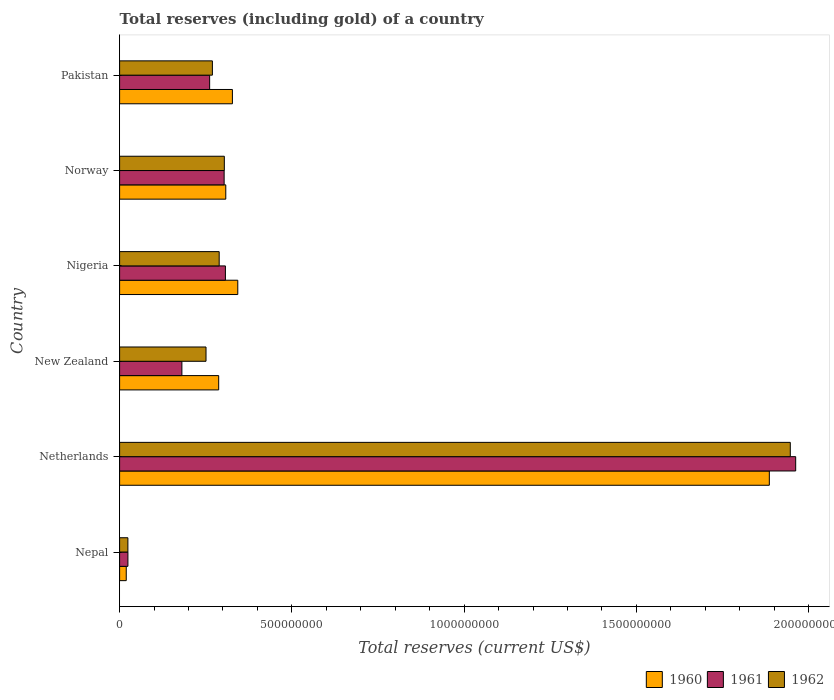How many groups of bars are there?
Provide a short and direct response. 6. Are the number of bars on each tick of the Y-axis equal?
Offer a very short reply. Yes. How many bars are there on the 1st tick from the bottom?
Provide a short and direct response. 3. What is the total reserves (including gold) in 1961 in New Zealand?
Provide a succinct answer. 1.81e+08. Across all countries, what is the maximum total reserves (including gold) in 1961?
Provide a short and direct response. 1.96e+09. Across all countries, what is the minimum total reserves (including gold) in 1961?
Keep it short and to the point. 2.41e+07. In which country was the total reserves (including gold) in 1960 maximum?
Make the answer very short. Netherlands. In which country was the total reserves (including gold) in 1962 minimum?
Offer a terse response. Nepal. What is the total total reserves (including gold) in 1960 in the graph?
Provide a short and direct response. 3.17e+09. What is the difference between the total reserves (including gold) in 1961 in Netherlands and that in Norway?
Your answer should be compact. 1.66e+09. What is the difference between the total reserves (including gold) in 1961 in Norway and the total reserves (including gold) in 1962 in Nigeria?
Provide a succinct answer. 1.44e+07. What is the average total reserves (including gold) in 1960 per country?
Offer a terse response. 5.29e+08. What is the difference between the total reserves (including gold) in 1961 and total reserves (including gold) in 1960 in Pakistan?
Ensure brevity in your answer.  -6.61e+07. In how many countries, is the total reserves (including gold) in 1960 greater than 1000000000 US$?
Offer a terse response. 1. What is the ratio of the total reserves (including gold) in 1960 in Nigeria to that in Norway?
Your answer should be very brief. 1.11. Is the total reserves (including gold) in 1960 in Netherlands less than that in Nigeria?
Your answer should be very brief. No. Is the difference between the total reserves (including gold) in 1961 in Nepal and Norway greater than the difference between the total reserves (including gold) in 1960 in Nepal and Norway?
Your answer should be very brief. Yes. What is the difference between the highest and the second highest total reserves (including gold) in 1961?
Make the answer very short. 1.66e+09. What is the difference between the highest and the lowest total reserves (including gold) in 1962?
Your response must be concise. 1.92e+09. In how many countries, is the total reserves (including gold) in 1962 greater than the average total reserves (including gold) in 1962 taken over all countries?
Give a very brief answer. 1. Is the sum of the total reserves (including gold) in 1961 in Netherlands and Nigeria greater than the maximum total reserves (including gold) in 1960 across all countries?
Your answer should be compact. Yes. What does the 2nd bar from the top in Pakistan represents?
Give a very brief answer. 1961. How many bars are there?
Your response must be concise. 18. Are all the bars in the graph horizontal?
Keep it short and to the point. Yes. How many countries are there in the graph?
Make the answer very short. 6. What is the difference between two consecutive major ticks on the X-axis?
Provide a succinct answer. 5.00e+08. Are the values on the major ticks of X-axis written in scientific E-notation?
Keep it short and to the point. No. Does the graph contain any zero values?
Your response must be concise. No. Where does the legend appear in the graph?
Make the answer very short. Bottom right. How many legend labels are there?
Offer a very short reply. 3. What is the title of the graph?
Make the answer very short. Total reserves (including gold) of a country. Does "2009" appear as one of the legend labels in the graph?
Give a very brief answer. No. What is the label or title of the X-axis?
Keep it short and to the point. Total reserves (current US$). What is the Total reserves (current US$) of 1960 in Nepal?
Give a very brief answer. 1.93e+07. What is the Total reserves (current US$) of 1961 in Nepal?
Make the answer very short. 2.41e+07. What is the Total reserves (current US$) in 1962 in Nepal?
Your answer should be very brief. 2.40e+07. What is the Total reserves (current US$) of 1960 in Netherlands?
Make the answer very short. 1.89e+09. What is the Total reserves (current US$) in 1961 in Netherlands?
Ensure brevity in your answer.  1.96e+09. What is the Total reserves (current US$) of 1962 in Netherlands?
Offer a very short reply. 1.95e+09. What is the Total reserves (current US$) of 1960 in New Zealand?
Provide a short and direct response. 2.88e+08. What is the Total reserves (current US$) of 1961 in New Zealand?
Keep it short and to the point. 1.81e+08. What is the Total reserves (current US$) of 1962 in New Zealand?
Your response must be concise. 2.51e+08. What is the Total reserves (current US$) in 1960 in Nigeria?
Provide a succinct answer. 3.43e+08. What is the Total reserves (current US$) in 1961 in Nigeria?
Make the answer very short. 3.07e+08. What is the Total reserves (current US$) in 1962 in Nigeria?
Give a very brief answer. 2.89e+08. What is the Total reserves (current US$) of 1960 in Norway?
Give a very brief answer. 3.08e+08. What is the Total reserves (current US$) in 1961 in Norway?
Your answer should be compact. 3.03e+08. What is the Total reserves (current US$) in 1962 in Norway?
Offer a terse response. 3.04e+08. What is the Total reserves (current US$) in 1960 in Pakistan?
Your answer should be very brief. 3.27e+08. What is the Total reserves (current US$) of 1961 in Pakistan?
Offer a very short reply. 2.61e+08. What is the Total reserves (current US$) of 1962 in Pakistan?
Provide a short and direct response. 2.69e+08. Across all countries, what is the maximum Total reserves (current US$) in 1960?
Your answer should be very brief. 1.89e+09. Across all countries, what is the maximum Total reserves (current US$) of 1961?
Your response must be concise. 1.96e+09. Across all countries, what is the maximum Total reserves (current US$) in 1962?
Give a very brief answer. 1.95e+09. Across all countries, what is the minimum Total reserves (current US$) in 1960?
Your answer should be very brief. 1.93e+07. Across all countries, what is the minimum Total reserves (current US$) in 1961?
Offer a very short reply. 2.41e+07. Across all countries, what is the minimum Total reserves (current US$) of 1962?
Give a very brief answer. 2.40e+07. What is the total Total reserves (current US$) of 1960 in the graph?
Provide a succinct answer. 3.17e+09. What is the total Total reserves (current US$) of 1961 in the graph?
Your answer should be compact. 3.04e+09. What is the total Total reserves (current US$) of 1962 in the graph?
Your response must be concise. 3.08e+09. What is the difference between the Total reserves (current US$) of 1960 in Nepal and that in Netherlands?
Provide a short and direct response. -1.87e+09. What is the difference between the Total reserves (current US$) in 1961 in Nepal and that in Netherlands?
Offer a terse response. -1.94e+09. What is the difference between the Total reserves (current US$) of 1962 in Nepal and that in Netherlands?
Ensure brevity in your answer.  -1.92e+09. What is the difference between the Total reserves (current US$) of 1960 in Nepal and that in New Zealand?
Your response must be concise. -2.68e+08. What is the difference between the Total reserves (current US$) of 1961 in Nepal and that in New Zealand?
Ensure brevity in your answer.  -1.57e+08. What is the difference between the Total reserves (current US$) of 1962 in Nepal and that in New Zealand?
Provide a succinct answer. -2.27e+08. What is the difference between the Total reserves (current US$) in 1960 in Nepal and that in Nigeria?
Provide a succinct answer. -3.24e+08. What is the difference between the Total reserves (current US$) of 1961 in Nepal and that in Nigeria?
Your answer should be compact. -2.83e+08. What is the difference between the Total reserves (current US$) in 1962 in Nepal and that in Nigeria?
Ensure brevity in your answer.  -2.65e+08. What is the difference between the Total reserves (current US$) in 1960 in Nepal and that in Norway?
Provide a succinct answer. -2.89e+08. What is the difference between the Total reserves (current US$) of 1961 in Nepal and that in Norway?
Your response must be concise. -2.79e+08. What is the difference between the Total reserves (current US$) in 1962 in Nepal and that in Norway?
Offer a very short reply. -2.80e+08. What is the difference between the Total reserves (current US$) in 1960 in Nepal and that in Pakistan?
Your answer should be compact. -3.08e+08. What is the difference between the Total reserves (current US$) in 1961 in Nepal and that in Pakistan?
Provide a succinct answer. -2.37e+08. What is the difference between the Total reserves (current US$) of 1962 in Nepal and that in Pakistan?
Your answer should be very brief. -2.45e+08. What is the difference between the Total reserves (current US$) in 1960 in Netherlands and that in New Zealand?
Ensure brevity in your answer.  1.60e+09. What is the difference between the Total reserves (current US$) in 1961 in Netherlands and that in New Zealand?
Ensure brevity in your answer.  1.78e+09. What is the difference between the Total reserves (current US$) in 1962 in Netherlands and that in New Zealand?
Offer a very short reply. 1.70e+09. What is the difference between the Total reserves (current US$) in 1960 in Netherlands and that in Nigeria?
Your response must be concise. 1.54e+09. What is the difference between the Total reserves (current US$) of 1961 in Netherlands and that in Nigeria?
Keep it short and to the point. 1.66e+09. What is the difference between the Total reserves (current US$) in 1962 in Netherlands and that in Nigeria?
Ensure brevity in your answer.  1.66e+09. What is the difference between the Total reserves (current US$) in 1960 in Netherlands and that in Norway?
Provide a succinct answer. 1.58e+09. What is the difference between the Total reserves (current US$) of 1961 in Netherlands and that in Norway?
Provide a succinct answer. 1.66e+09. What is the difference between the Total reserves (current US$) in 1962 in Netherlands and that in Norway?
Provide a succinct answer. 1.64e+09. What is the difference between the Total reserves (current US$) of 1960 in Netherlands and that in Pakistan?
Offer a terse response. 1.56e+09. What is the difference between the Total reserves (current US$) in 1961 in Netherlands and that in Pakistan?
Make the answer very short. 1.70e+09. What is the difference between the Total reserves (current US$) of 1962 in Netherlands and that in Pakistan?
Provide a short and direct response. 1.68e+09. What is the difference between the Total reserves (current US$) of 1960 in New Zealand and that in Nigeria?
Your response must be concise. -5.54e+07. What is the difference between the Total reserves (current US$) of 1961 in New Zealand and that in Nigeria?
Offer a very short reply. -1.26e+08. What is the difference between the Total reserves (current US$) in 1962 in New Zealand and that in Nigeria?
Make the answer very short. -3.82e+07. What is the difference between the Total reserves (current US$) of 1960 in New Zealand and that in Norway?
Ensure brevity in your answer.  -2.06e+07. What is the difference between the Total reserves (current US$) of 1961 in New Zealand and that in Norway?
Offer a terse response. -1.23e+08. What is the difference between the Total reserves (current US$) in 1962 in New Zealand and that in Norway?
Offer a very short reply. -5.32e+07. What is the difference between the Total reserves (current US$) of 1960 in New Zealand and that in Pakistan?
Give a very brief answer. -3.98e+07. What is the difference between the Total reserves (current US$) in 1961 in New Zealand and that in Pakistan?
Make the answer very short. -8.05e+07. What is the difference between the Total reserves (current US$) of 1962 in New Zealand and that in Pakistan?
Your response must be concise. -1.85e+07. What is the difference between the Total reserves (current US$) of 1960 in Nigeria and that in Norway?
Give a very brief answer. 3.48e+07. What is the difference between the Total reserves (current US$) in 1961 in Nigeria and that in Norway?
Your answer should be very brief. 3.64e+06. What is the difference between the Total reserves (current US$) of 1962 in Nigeria and that in Norway?
Provide a short and direct response. -1.50e+07. What is the difference between the Total reserves (current US$) in 1960 in Nigeria and that in Pakistan?
Your response must be concise. 1.56e+07. What is the difference between the Total reserves (current US$) of 1961 in Nigeria and that in Pakistan?
Your response must be concise. 4.58e+07. What is the difference between the Total reserves (current US$) in 1962 in Nigeria and that in Pakistan?
Keep it short and to the point. 1.97e+07. What is the difference between the Total reserves (current US$) of 1960 in Norway and that in Pakistan?
Offer a terse response. -1.92e+07. What is the difference between the Total reserves (current US$) of 1961 in Norway and that in Pakistan?
Your answer should be very brief. 4.21e+07. What is the difference between the Total reserves (current US$) of 1962 in Norway and that in Pakistan?
Offer a terse response. 3.47e+07. What is the difference between the Total reserves (current US$) of 1960 in Nepal and the Total reserves (current US$) of 1961 in Netherlands?
Offer a terse response. -1.94e+09. What is the difference between the Total reserves (current US$) of 1960 in Nepal and the Total reserves (current US$) of 1962 in Netherlands?
Give a very brief answer. -1.93e+09. What is the difference between the Total reserves (current US$) in 1961 in Nepal and the Total reserves (current US$) in 1962 in Netherlands?
Provide a succinct answer. -1.92e+09. What is the difference between the Total reserves (current US$) in 1960 in Nepal and the Total reserves (current US$) in 1961 in New Zealand?
Offer a terse response. -1.62e+08. What is the difference between the Total reserves (current US$) in 1960 in Nepal and the Total reserves (current US$) in 1962 in New Zealand?
Provide a short and direct response. -2.32e+08. What is the difference between the Total reserves (current US$) in 1961 in Nepal and the Total reserves (current US$) in 1962 in New Zealand?
Offer a very short reply. -2.27e+08. What is the difference between the Total reserves (current US$) of 1960 in Nepal and the Total reserves (current US$) of 1961 in Nigeria?
Give a very brief answer. -2.88e+08. What is the difference between the Total reserves (current US$) in 1960 in Nepal and the Total reserves (current US$) in 1962 in Nigeria?
Give a very brief answer. -2.70e+08. What is the difference between the Total reserves (current US$) in 1961 in Nepal and the Total reserves (current US$) in 1962 in Nigeria?
Provide a succinct answer. -2.65e+08. What is the difference between the Total reserves (current US$) of 1960 in Nepal and the Total reserves (current US$) of 1961 in Norway?
Provide a short and direct response. -2.84e+08. What is the difference between the Total reserves (current US$) in 1960 in Nepal and the Total reserves (current US$) in 1962 in Norway?
Offer a very short reply. -2.85e+08. What is the difference between the Total reserves (current US$) of 1961 in Nepal and the Total reserves (current US$) of 1962 in Norway?
Your answer should be compact. -2.80e+08. What is the difference between the Total reserves (current US$) of 1960 in Nepal and the Total reserves (current US$) of 1961 in Pakistan?
Your response must be concise. -2.42e+08. What is the difference between the Total reserves (current US$) in 1960 in Nepal and the Total reserves (current US$) in 1962 in Pakistan?
Give a very brief answer. -2.50e+08. What is the difference between the Total reserves (current US$) of 1961 in Nepal and the Total reserves (current US$) of 1962 in Pakistan?
Your answer should be very brief. -2.45e+08. What is the difference between the Total reserves (current US$) in 1960 in Netherlands and the Total reserves (current US$) in 1961 in New Zealand?
Your response must be concise. 1.70e+09. What is the difference between the Total reserves (current US$) in 1960 in Netherlands and the Total reserves (current US$) in 1962 in New Zealand?
Your answer should be compact. 1.63e+09. What is the difference between the Total reserves (current US$) of 1961 in Netherlands and the Total reserves (current US$) of 1962 in New Zealand?
Your answer should be very brief. 1.71e+09. What is the difference between the Total reserves (current US$) of 1960 in Netherlands and the Total reserves (current US$) of 1961 in Nigeria?
Make the answer very short. 1.58e+09. What is the difference between the Total reserves (current US$) in 1960 in Netherlands and the Total reserves (current US$) in 1962 in Nigeria?
Offer a terse response. 1.60e+09. What is the difference between the Total reserves (current US$) of 1961 in Netherlands and the Total reserves (current US$) of 1962 in Nigeria?
Offer a very short reply. 1.67e+09. What is the difference between the Total reserves (current US$) of 1960 in Netherlands and the Total reserves (current US$) of 1961 in Norway?
Offer a terse response. 1.58e+09. What is the difference between the Total reserves (current US$) in 1960 in Netherlands and the Total reserves (current US$) in 1962 in Norway?
Keep it short and to the point. 1.58e+09. What is the difference between the Total reserves (current US$) in 1961 in Netherlands and the Total reserves (current US$) in 1962 in Norway?
Provide a succinct answer. 1.66e+09. What is the difference between the Total reserves (current US$) of 1960 in Netherlands and the Total reserves (current US$) of 1961 in Pakistan?
Offer a terse response. 1.62e+09. What is the difference between the Total reserves (current US$) in 1960 in Netherlands and the Total reserves (current US$) in 1962 in Pakistan?
Give a very brief answer. 1.62e+09. What is the difference between the Total reserves (current US$) of 1961 in Netherlands and the Total reserves (current US$) of 1962 in Pakistan?
Offer a terse response. 1.69e+09. What is the difference between the Total reserves (current US$) in 1960 in New Zealand and the Total reserves (current US$) in 1961 in Nigeria?
Offer a very short reply. -1.95e+07. What is the difference between the Total reserves (current US$) of 1960 in New Zealand and the Total reserves (current US$) of 1962 in Nigeria?
Your response must be concise. -1.43e+06. What is the difference between the Total reserves (current US$) of 1961 in New Zealand and the Total reserves (current US$) of 1962 in Nigeria?
Your answer should be compact. -1.08e+08. What is the difference between the Total reserves (current US$) of 1960 in New Zealand and the Total reserves (current US$) of 1961 in Norway?
Give a very brief answer. -1.58e+07. What is the difference between the Total reserves (current US$) of 1960 in New Zealand and the Total reserves (current US$) of 1962 in Norway?
Give a very brief answer. -1.64e+07. What is the difference between the Total reserves (current US$) of 1961 in New Zealand and the Total reserves (current US$) of 1962 in Norway?
Offer a very short reply. -1.23e+08. What is the difference between the Total reserves (current US$) of 1960 in New Zealand and the Total reserves (current US$) of 1961 in Pakistan?
Keep it short and to the point. 2.63e+07. What is the difference between the Total reserves (current US$) of 1960 in New Zealand and the Total reserves (current US$) of 1962 in Pakistan?
Offer a terse response. 1.83e+07. What is the difference between the Total reserves (current US$) of 1961 in New Zealand and the Total reserves (current US$) of 1962 in Pakistan?
Provide a short and direct response. -8.85e+07. What is the difference between the Total reserves (current US$) of 1960 in Nigeria and the Total reserves (current US$) of 1961 in Norway?
Offer a terse response. 3.96e+07. What is the difference between the Total reserves (current US$) in 1960 in Nigeria and the Total reserves (current US$) in 1962 in Norway?
Make the answer very short. 3.90e+07. What is the difference between the Total reserves (current US$) of 1961 in Nigeria and the Total reserves (current US$) of 1962 in Norway?
Provide a short and direct response. 3.09e+06. What is the difference between the Total reserves (current US$) of 1960 in Nigeria and the Total reserves (current US$) of 1961 in Pakistan?
Your answer should be compact. 8.17e+07. What is the difference between the Total reserves (current US$) in 1960 in Nigeria and the Total reserves (current US$) in 1962 in Pakistan?
Give a very brief answer. 7.37e+07. What is the difference between the Total reserves (current US$) of 1961 in Nigeria and the Total reserves (current US$) of 1962 in Pakistan?
Your response must be concise. 3.78e+07. What is the difference between the Total reserves (current US$) in 1960 in Norway and the Total reserves (current US$) in 1961 in Pakistan?
Your answer should be very brief. 4.69e+07. What is the difference between the Total reserves (current US$) of 1960 in Norway and the Total reserves (current US$) of 1962 in Pakistan?
Ensure brevity in your answer.  3.89e+07. What is the difference between the Total reserves (current US$) of 1961 in Norway and the Total reserves (current US$) of 1962 in Pakistan?
Your answer should be very brief. 3.41e+07. What is the average Total reserves (current US$) in 1960 per country?
Give a very brief answer. 5.29e+08. What is the average Total reserves (current US$) of 1961 per country?
Provide a succinct answer. 5.07e+08. What is the average Total reserves (current US$) of 1962 per country?
Make the answer very short. 5.14e+08. What is the difference between the Total reserves (current US$) in 1960 and Total reserves (current US$) in 1961 in Nepal?
Provide a succinct answer. -4.88e+06. What is the difference between the Total reserves (current US$) of 1960 and Total reserves (current US$) of 1962 in Nepal?
Offer a very short reply. -4.77e+06. What is the difference between the Total reserves (current US$) in 1961 and Total reserves (current US$) in 1962 in Nepal?
Give a very brief answer. 1.04e+05. What is the difference between the Total reserves (current US$) in 1960 and Total reserves (current US$) in 1961 in Netherlands?
Ensure brevity in your answer.  -7.65e+07. What is the difference between the Total reserves (current US$) in 1960 and Total reserves (current US$) in 1962 in Netherlands?
Your response must be concise. -6.09e+07. What is the difference between the Total reserves (current US$) of 1961 and Total reserves (current US$) of 1962 in Netherlands?
Make the answer very short. 1.56e+07. What is the difference between the Total reserves (current US$) of 1960 and Total reserves (current US$) of 1961 in New Zealand?
Your answer should be compact. 1.07e+08. What is the difference between the Total reserves (current US$) in 1960 and Total reserves (current US$) in 1962 in New Zealand?
Ensure brevity in your answer.  3.68e+07. What is the difference between the Total reserves (current US$) in 1961 and Total reserves (current US$) in 1962 in New Zealand?
Offer a very short reply. -7.00e+07. What is the difference between the Total reserves (current US$) of 1960 and Total reserves (current US$) of 1961 in Nigeria?
Give a very brief answer. 3.59e+07. What is the difference between the Total reserves (current US$) in 1960 and Total reserves (current US$) in 1962 in Nigeria?
Offer a very short reply. 5.40e+07. What is the difference between the Total reserves (current US$) of 1961 and Total reserves (current US$) of 1962 in Nigeria?
Ensure brevity in your answer.  1.80e+07. What is the difference between the Total reserves (current US$) of 1960 and Total reserves (current US$) of 1961 in Norway?
Keep it short and to the point. 4.75e+06. What is the difference between the Total reserves (current US$) in 1960 and Total reserves (current US$) in 1962 in Norway?
Keep it short and to the point. 4.20e+06. What is the difference between the Total reserves (current US$) of 1961 and Total reserves (current US$) of 1962 in Norway?
Give a very brief answer. -5.46e+05. What is the difference between the Total reserves (current US$) of 1960 and Total reserves (current US$) of 1961 in Pakistan?
Provide a succinct answer. 6.61e+07. What is the difference between the Total reserves (current US$) in 1960 and Total reserves (current US$) in 1962 in Pakistan?
Offer a terse response. 5.81e+07. What is the difference between the Total reserves (current US$) in 1961 and Total reserves (current US$) in 1962 in Pakistan?
Keep it short and to the point. -8.01e+06. What is the ratio of the Total reserves (current US$) in 1960 in Nepal to that in Netherlands?
Offer a terse response. 0.01. What is the ratio of the Total reserves (current US$) in 1961 in Nepal to that in Netherlands?
Give a very brief answer. 0.01. What is the ratio of the Total reserves (current US$) of 1962 in Nepal to that in Netherlands?
Provide a succinct answer. 0.01. What is the ratio of the Total reserves (current US$) in 1960 in Nepal to that in New Zealand?
Offer a very short reply. 0.07. What is the ratio of the Total reserves (current US$) of 1961 in Nepal to that in New Zealand?
Your answer should be very brief. 0.13. What is the ratio of the Total reserves (current US$) of 1962 in Nepal to that in New Zealand?
Keep it short and to the point. 0.1. What is the ratio of the Total reserves (current US$) in 1960 in Nepal to that in Nigeria?
Keep it short and to the point. 0.06. What is the ratio of the Total reserves (current US$) of 1961 in Nepal to that in Nigeria?
Give a very brief answer. 0.08. What is the ratio of the Total reserves (current US$) in 1962 in Nepal to that in Nigeria?
Provide a succinct answer. 0.08. What is the ratio of the Total reserves (current US$) in 1960 in Nepal to that in Norway?
Provide a short and direct response. 0.06. What is the ratio of the Total reserves (current US$) of 1961 in Nepal to that in Norway?
Provide a short and direct response. 0.08. What is the ratio of the Total reserves (current US$) of 1962 in Nepal to that in Norway?
Provide a succinct answer. 0.08. What is the ratio of the Total reserves (current US$) in 1960 in Nepal to that in Pakistan?
Provide a short and direct response. 0.06. What is the ratio of the Total reserves (current US$) of 1961 in Nepal to that in Pakistan?
Your answer should be very brief. 0.09. What is the ratio of the Total reserves (current US$) in 1962 in Nepal to that in Pakistan?
Keep it short and to the point. 0.09. What is the ratio of the Total reserves (current US$) of 1960 in Netherlands to that in New Zealand?
Make the answer very short. 6.56. What is the ratio of the Total reserves (current US$) in 1961 in Netherlands to that in New Zealand?
Offer a terse response. 10.85. What is the ratio of the Total reserves (current US$) in 1962 in Netherlands to that in New Zealand?
Your response must be concise. 7.76. What is the ratio of the Total reserves (current US$) in 1960 in Netherlands to that in Nigeria?
Provide a short and direct response. 5.5. What is the ratio of the Total reserves (current US$) in 1961 in Netherlands to that in Nigeria?
Provide a short and direct response. 6.39. What is the ratio of the Total reserves (current US$) in 1962 in Netherlands to that in Nigeria?
Keep it short and to the point. 6.74. What is the ratio of the Total reserves (current US$) in 1960 in Netherlands to that in Norway?
Provide a succinct answer. 6.12. What is the ratio of the Total reserves (current US$) in 1961 in Netherlands to that in Norway?
Your answer should be compact. 6.47. What is the ratio of the Total reserves (current US$) in 1962 in Netherlands to that in Norway?
Provide a short and direct response. 6.4. What is the ratio of the Total reserves (current US$) in 1960 in Netherlands to that in Pakistan?
Ensure brevity in your answer.  5.76. What is the ratio of the Total reserves (current US$) of 1961 in Netherlands to that in Pakistan?
Your response must be concise. 7.51. What is the ratio of the Total reserves (current US$) of 1962 in Netherlands to that in Pakistan?
Offer a terse response. 7.23. What is the ratio of the Total reserves (current US$) in 1960 in New Zealand to that in Nigeria?
Your response must be concise. 0.84. What is the ratio of the Total reserves (current US$) of 1961 in New Zealand to that in Nigeria?
Offer a terse response. 0.59. What is the ratio of the Total reserves (current US$) of 1962 in New Zealand to that in Nigeria?
Offer a very short reply. 0.87. What is the ratio of the Total reserves (current US$) in 1960 in New Zealand to that in Norway?
Provide a short and direct response. 0.93. What is the ratio of the Total reserves (current US$) in 1961 in New Zealand to that in Norway?
Offer a terse response. 0.6. What is the ratio of the Total reserves (current US$) in 1962 in New Zealand to that in Norway?
Offer a very short reply. 0.83. What is the ratio of the Total reserves (current US$) in 1960 in New Zealand to that in Pakistan?
Your answer should be compact. 0.88. What is the ratio of the Total reserves (current US$) of 1961 in New Zealand to that in Pakistan?
Offer a terse response. 0.69. What is the ratio of the Total reserves (current US$) of 1962 in New Zealand to that in Pakistan?
Make the answer very short. 0.93. What is the ratio of the Total reserves (current US$) in 1960 in Nigeria to that in Norway?
Provide a short and direct response. 1.11. What is the ratio of the Total reserves (current US$) in 1961 in Nigeria to that in Norway?
Offer a terse response. 1.01. What is the ratio of the Total reserves (current US$) of 1962 in Nigeria to that in Norway?
Your answer should be very brief. 0.95. What is the ratio of the Total reserves (current US$) of 1960 in Nigeria to that in Pakistan?
Give a very brief answer. 1.05. What is the ratio of the Total reserves (current US$) in 1961 in Nigeria to that in Pakistan?
Your answer should be very brief. 1.18. What is the ratio of the Total reserves (current US$) of 1962 in Nigeria to that in Pakistan?
Provide a short and direct response. 1.07. What is the ratio of the Total reserves (current US$) of 1960 in Norway to that in Pakistan?
Offer a terse response. 0.94. What is the ratio of the Total reserves (current US$) of 1961 in Norway to that in Pakistan?
Keep it short and to the point. 1.16. What is the ratio of the Total reserves (current US$) in 1962 in Norway to that in Pakistan?
Offer a terse response. 1.13. What is the difference between the highest and the second highest Total reserves (current US$) of 1960?
Keep it short and to the point. 1.54e+09. What is the difference between the highest and the second highest Total reserves (current US$) in 1961?
Your answer should be compact. 1.66e+09. What is the difference between the highest and the second highest Total reserves (current US$) in 1962?
Make the answer very short. 1.64e+09. What is the difference between the highest and the lowest Total reserves (current US$) in 1960?
Your response must be concise. 1.87e+09. What is the difference between the highest and the lowest Total reserves (current US$) in 1961?
Provide a succinct answer. 1.94e+09. What is the difference between the highest and the lowest Total reserves (current US$) in 1962?
Offer a terse response. 1.92e+09. 